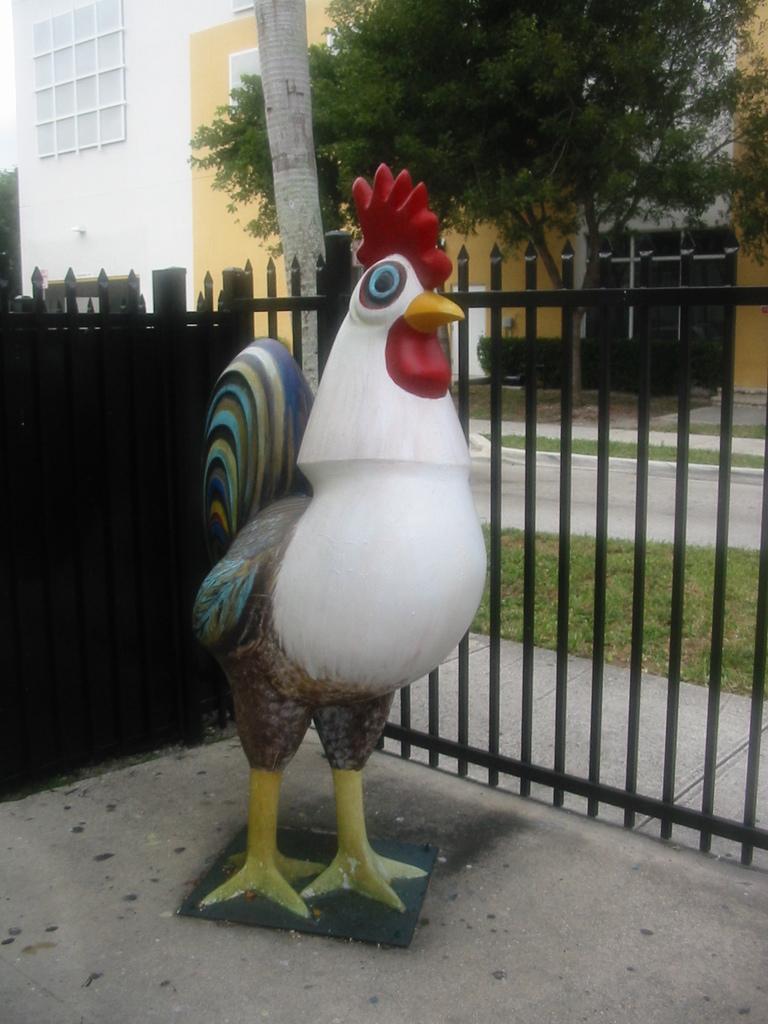Please provide a concise description of this image. In this image I can see depiction of a chicken. I can also see Iron bars, grass, a tree, few buildings and bushes over there. 